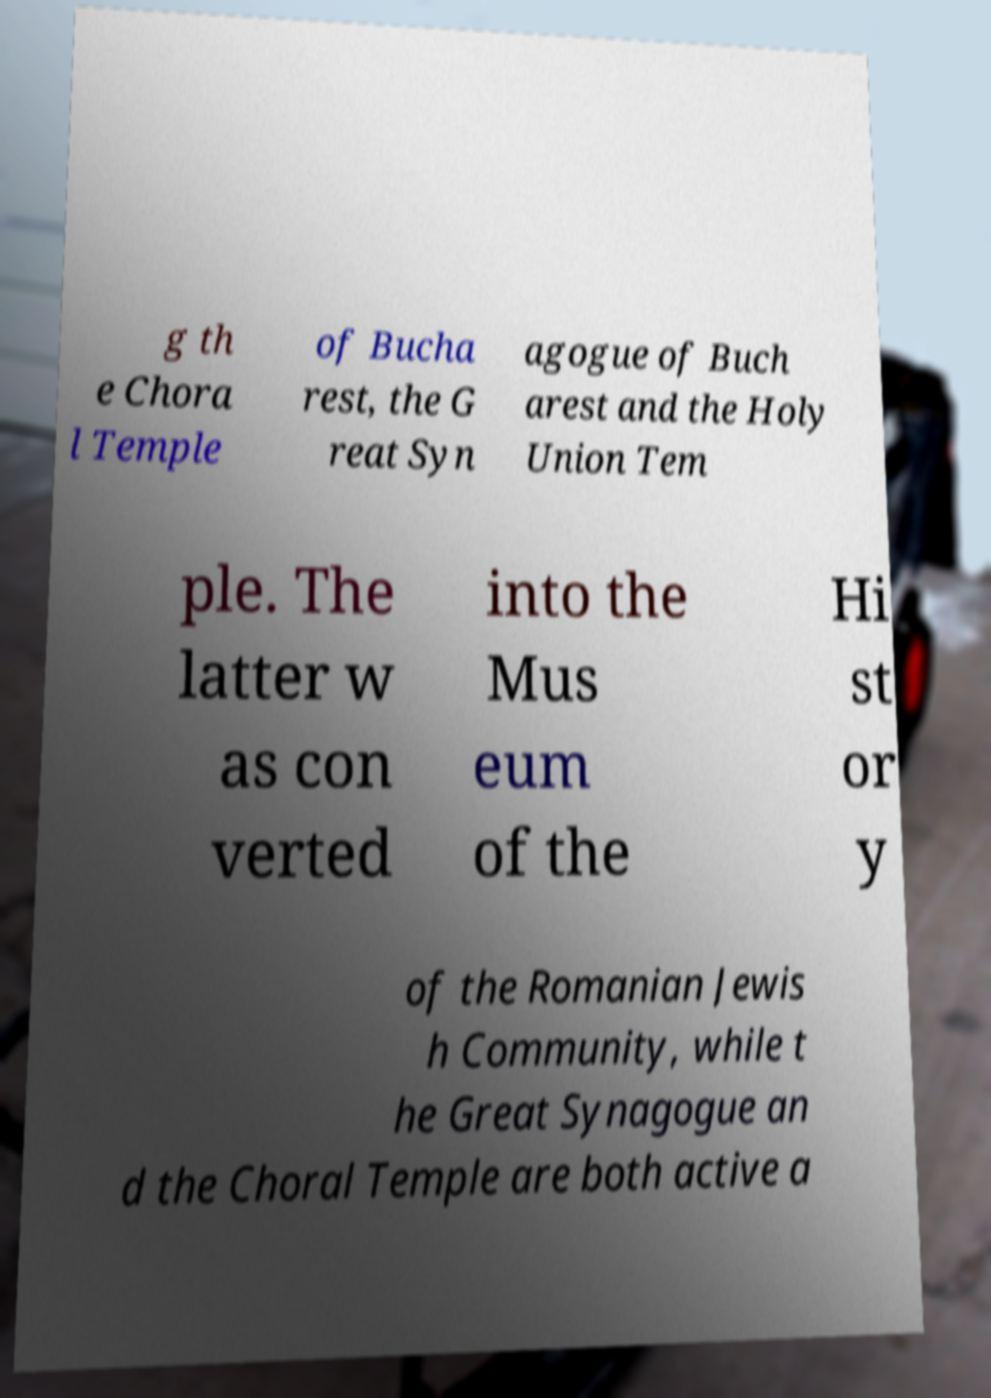What messages or text are displayed in this image? I need them in a readable, typed format. g th e Chora l Temple of Bucha rest, the G reat Syn agogue of Buch arest and the Holy Union Tem ple. The latter w as con verted into the Mus eum of the Hi st or y of the Romanian Jewis h Community, while t he Great Synagogue an d the Choral Temple are both active a 